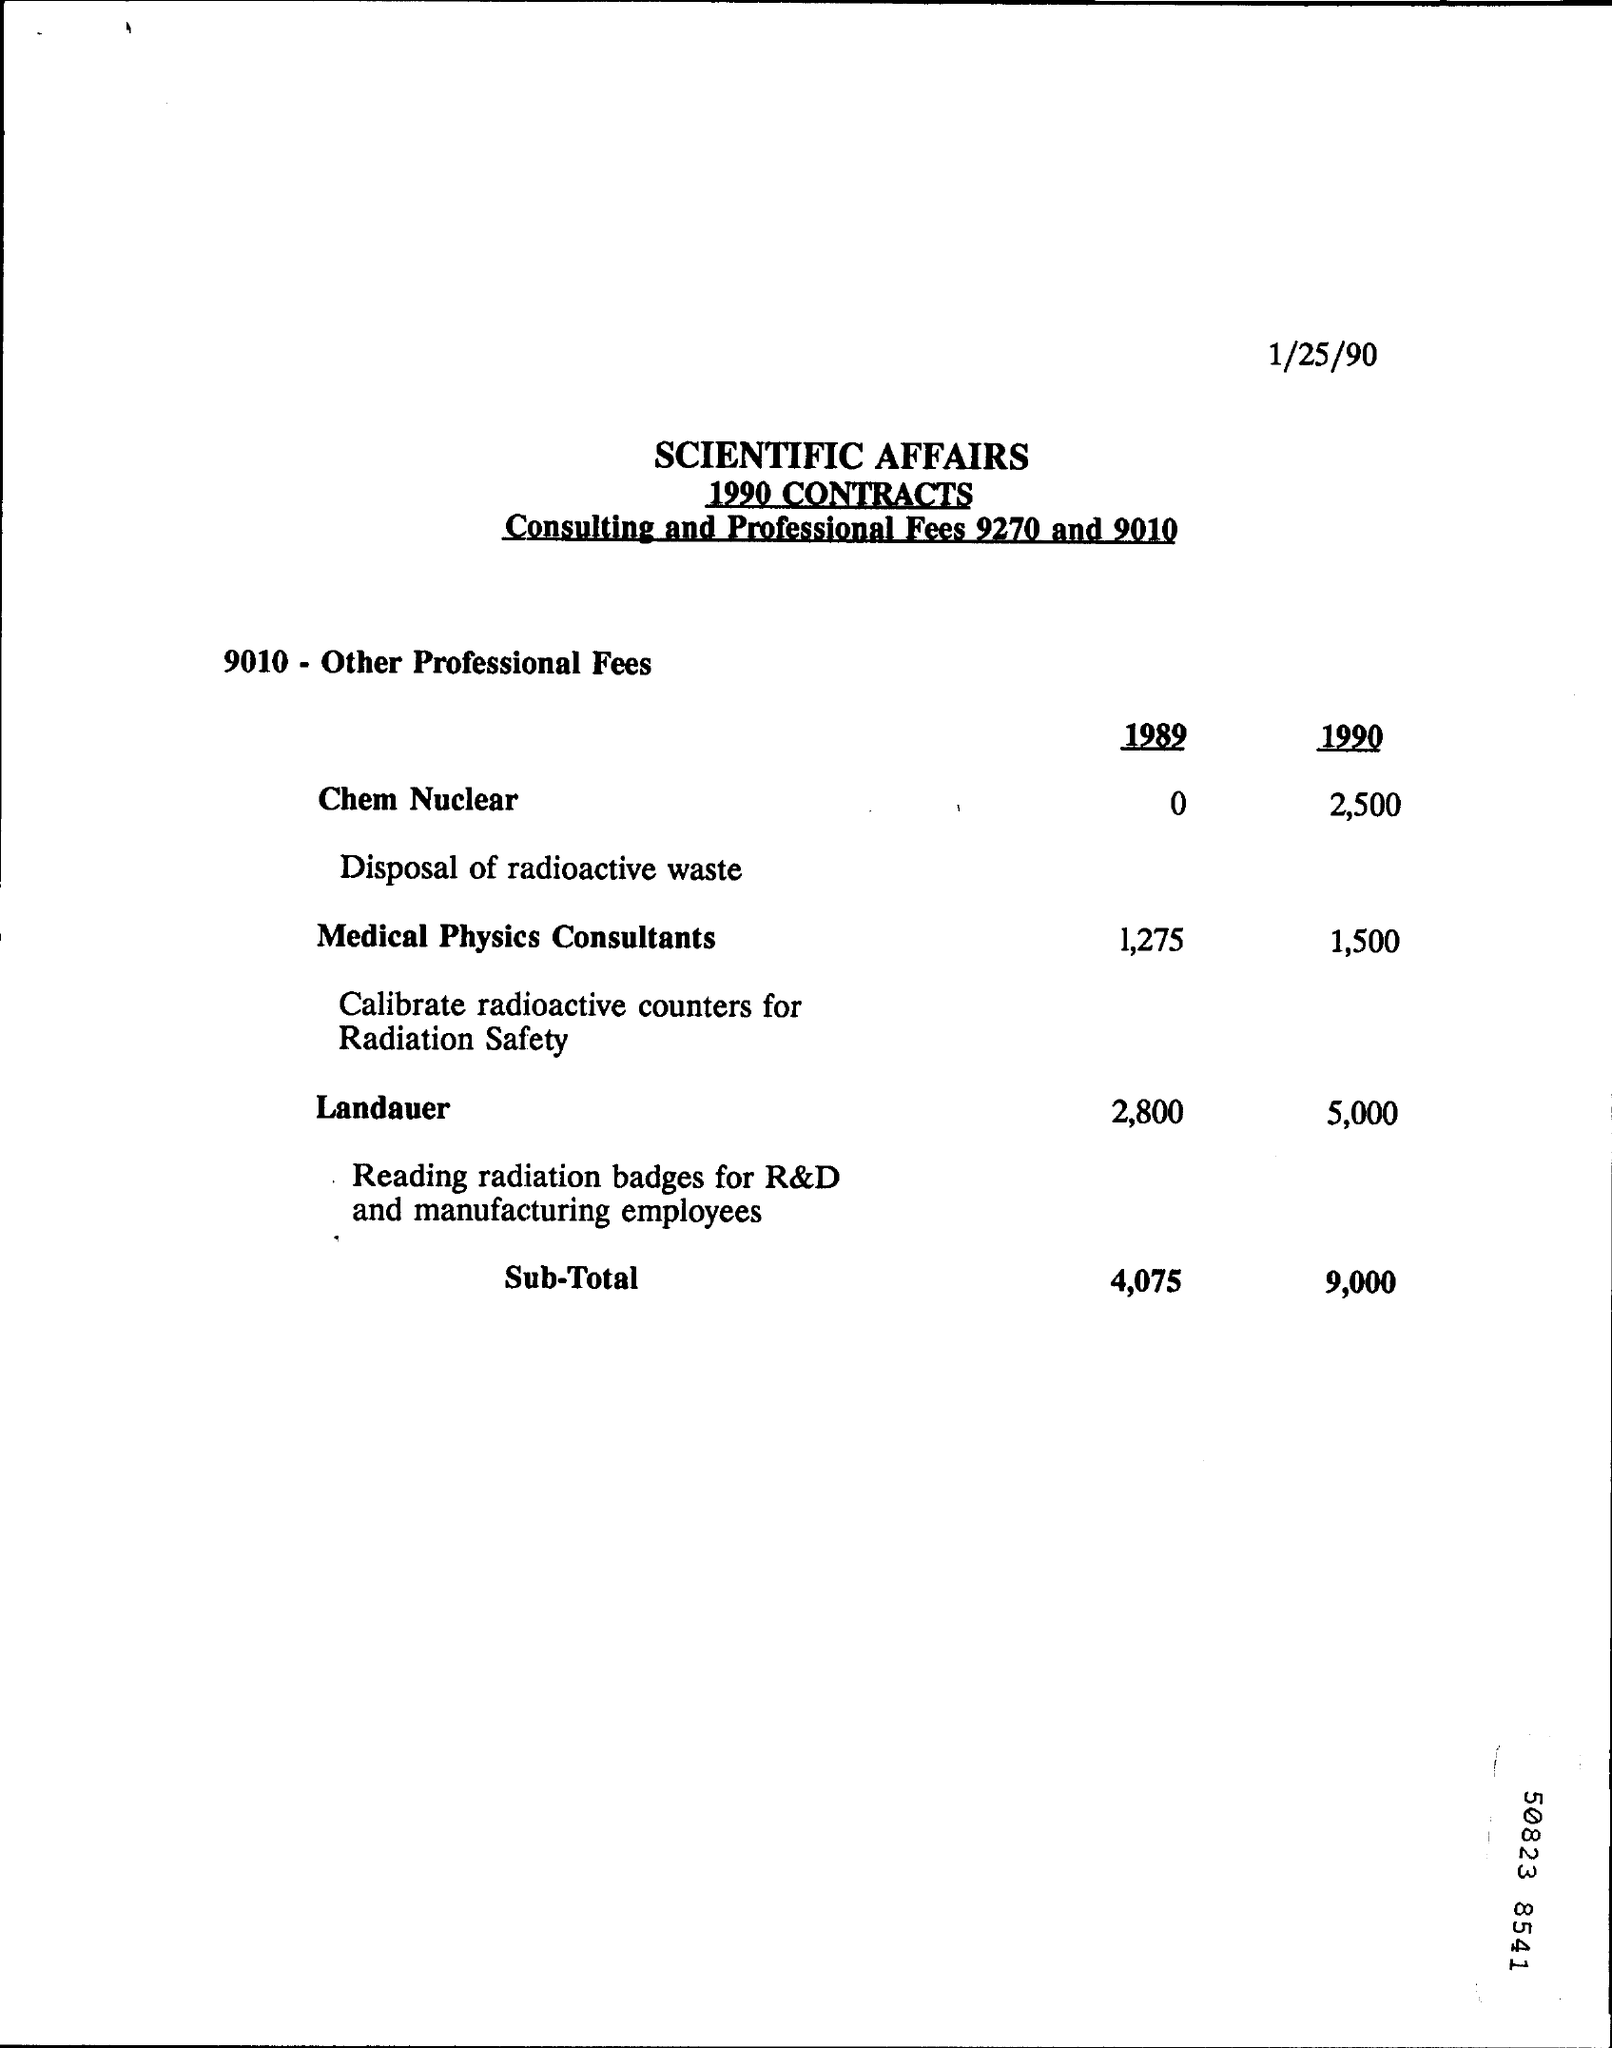What is the Chem Nuclear cost in 1990?
Give a very brief answer. 2,500. What is the fee for Medical Physics Consultants in 1989?
Offer a very short reply. 1,275. What is the fee for Medical Physics Consultants in 1990 ?
Your answer should be very brief. 1,500. What is the sub-total in 1989 ?
Give a very brief answer. 4,075. What is the sub-total in 1990 ?
Your response must be concise. 9,000. What is the Landauer fee in 1989 ?
Your response must be concise. 2,800. What is the Landauer fee in 1990 ?
Your answer should be very brief. 5,000. 